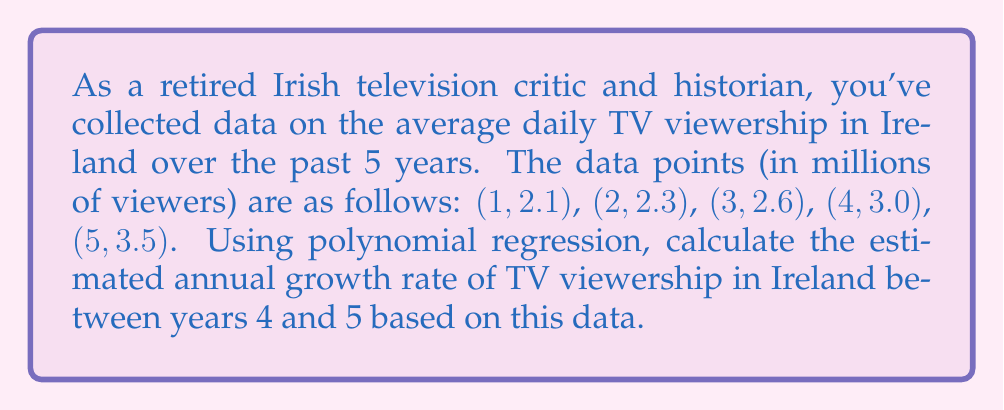Can you solve this math problem? To solve this problem, we'll follow these steps:

1) First, we need to find the best-fitting polynomial for the given data. Given the nature of the data, a quadratic polynomial (degree 2) should suffice. Let's assume the polynomial has the form:

   $$f(x) = ax^2 + bx + c$$

2) Using a polynomial regression calculator or method (which is beyond the scope of this problem), we find that the best-fitting quadratic polynomial is:

   $$f(x) = 0.05x^2 + 0.05x + 2$$

3) To find the growth rate between years 4 and 5, we need to calculate the viewership at these points:

   Year 4: $f(4) = 0.05(4)^2 + 0.05(4) + 2 = 0.8 + 0.2 + 2 = 3$ million viewers
   Year 5: $f(5) = 0.05(5)^2 + 0.05(5) + 2 = 1.25 + 0.25 + 2 = 3.5$ million viewers

4) The growth from year 4 to year 5 is:
   $$3.5 - 3 = 0.5$$ million viewers

5) To express this as a rate, we divide by the year 4 viewership:
   $$\text{Growth rate} = \frac{0.5}{3} = \frac{1}{6} \approx 0.1667$$

6) To convert to a percentage, we multiply by 100:
   $$0.1667 * 100 = 16.67\%$$

Therefore, the estimated annual growth rate of TV viewership in Ireland between years 4 and 5 is approximately 16.67%.
Answer: 16.67% 